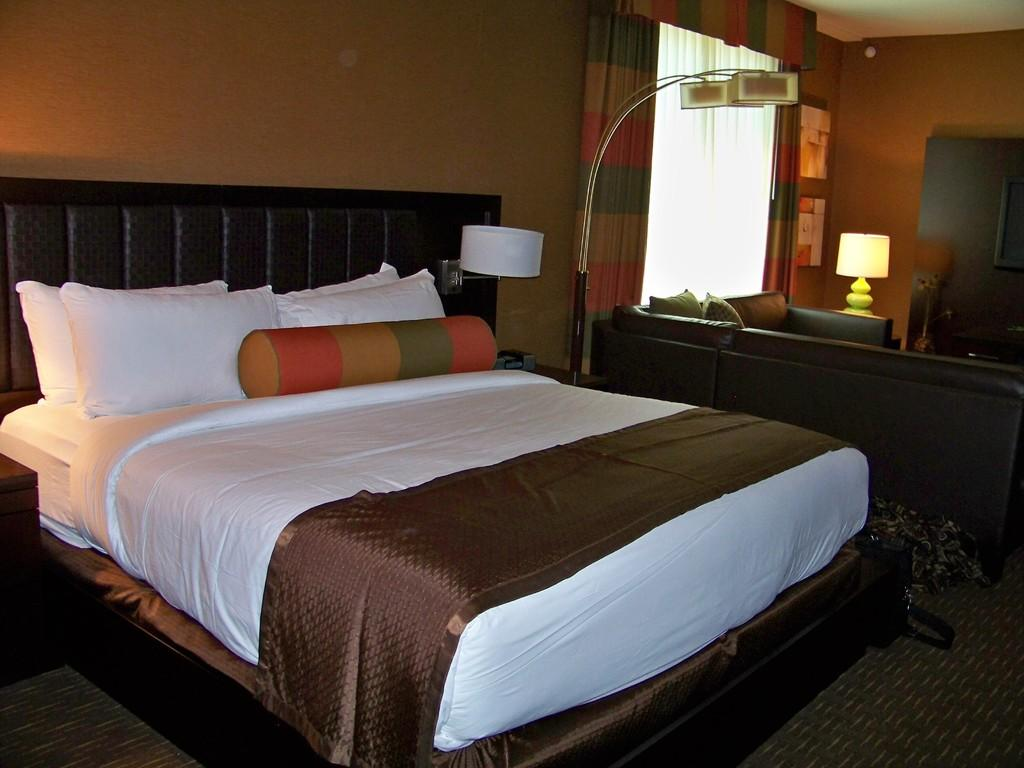What type of furniture is present in the image? There is a bed, pillows, and a sofa in the image. What type of lighting is present in the image? There is a lamp in the image. What type of window treatment is present in the image? There is a curtain in the image. What type of structure is present in the image? There is a wall in the image. What type of setting is the image likely taken in? The image is likely taken in a room. Can you hear the son laughing in the image? There is no son or laughter present in the image; it only shows a bed, pillows, a lamp, a sofa, a curtain, and a wall. 